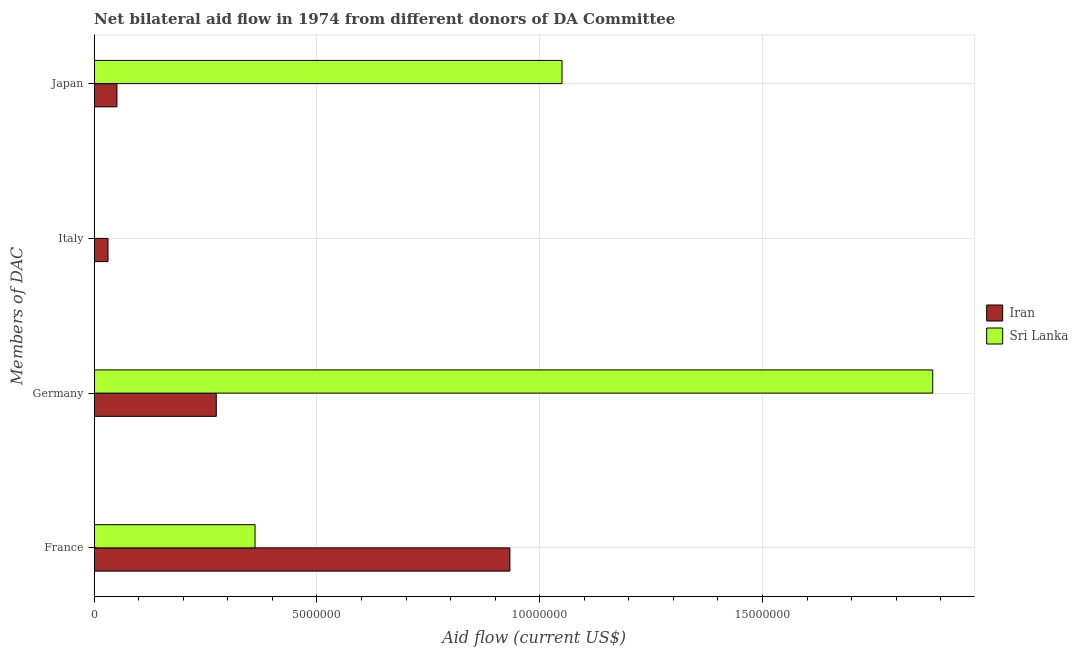Are the number of bars per tick equal to the number of legend labels?
Your answer should be compact. No. Are the number of bars on each tick of the Y-axis equal?
Your answer should be compact. No. How many bars are there on the 4th tick from the top?
Give a very brief answer. 2. What is the amount of aid given by france in Sri Lanka?
Provide a succinct answer. 3.61e+06. Across all countries, what is the maximum amount of aid given by germany?
Your answer should be compact. 1.88e+07. Across all countries, what is the minimum amount of aid given by italy?
Offer a very short reply. 0. In which country was the amount of aid given by italy maximum?
Your answer should be very brief. Iran. What is the total amount of aid given by france in the graph?
Ensure brevity in your answer.  1.29e+07. What is the difference between the amount of aid given by france in Iran and that in Sri Lanka?
Give a very brief answer. 5.72e+06. What is the difference between the amount of aid given by germany in Iran and the amount of aid given by italy in Sri Lanka?
Keep it short and to the point. 2.74e+06. What is the average amount of aid given by italy per country?
Your answer should be compact. 1.55e+05. What is the difference between the amount of aid given by germany and amount of aid given by italy in Iran?
Offer a terse response. 2.43e+06. In how many countries, is the amount of aid given by france greater than 12000000 US$?
Your answer should be compact. 0. What is the ratio of the amount of aid given by germany in Sri Lanka to that in Iran?
Offer a terse response. 6.87. Is the difference between the amount of aid given by france in Iran and Sri Lanka greater than the difference between the amount of aid given by japan in Iran and Sri Lanka?
Keep it short and to the point. Yes. What is the difference between the highest and the second highest amount of aid given by france?
Keep it short and to the point. 5.72e+06. What is the difference between the highest and the lowest amount of aid given by germany?
Ensure brevity in your answer.  1.61e+07. Are all the bars in the graph horizontal?
Make the answer very short. Yes. What is the difference between two consecutive major ticks on the X-axis?
Provide a short and direct response. 5.00e+06. Where does the legend appear in the graph?
Offer a very short reply. Center right. How many legend labels are there?
Ensure brevity in your answer.  2. How are the legend labels stacked?
Offer a very short reply. Vertical. What is the title of the graph?
Provide a succinct answer. Net bilateral aid flow in 1974 from different donors of DA Committee. What is the label or title of the Y-axis?
Give a very brief answer. Members of DAC. What is the Aid flow (current US$) of Iran in France?
Your answer should be compact. 9.33e+06. What is the Aid flow (current US$) in Sri Lanka in France?
Keep it short and to the point. 3.61e+06. What is the Aid flow (current US$) of Iran in Germany?
Make the answer very short. 2.74e+06. What is the Aid flow (current US$) in Sri Lanka in Germany?
Offer a very short reply. 1.88e+07. What is the Aid flow (current US$) in Sri Lanka in Italy?
Your answer should be compact. 0. What is the Aid flow (current US$) in Iran in Japan?
Your response must be concise. 5.10e+05. What is the Aid flow (current US$) in Sri Lanka in Japan?
Your answer should be very brief. 1.05e+07. Across all Members of DAC, what is the maximum Aid flow (current US$) in Iran?
Make the answer very short. 9.33e+06. Across all Members of DAC, what is the maximum Aid flow (current US$) in Sri Lanka?
Offer a very short reply. 1.88e+07. Across all Members of DAC, what is the minimum Aid flow (current US$) in Iran?
Give a very brief answer. 3.10e+05. Across all Members of DAC, what is the minimum Aid flow (current US$) in Sri Lanka?
Provide a short and direct response. 0. What is the total Aid flow (current US$) of Iran in the graph?
Your answer should be compact. 1.29e+07. What is the total Aid flow (current US$) in Sri Lanka in the graph?
Provide a short and direct response. 3.29e+07. What is the difference between the Aid flow (current US$) of Iran in France and that in Germany?
Your response must be concise. 6.59e+06. What is the difference between the Aid flow (current US$) in Sri Lanka in France and that in Germany?
Your answer should be very brief. -1.52e+07. What is the difference between the Aid flow (current US$) in Iran in France and that in Italy?
Offer a terse response. 9.02e+06. What is the difference between the Aid flow (current US$) of Iran in France and that in Japan?
Keep it short and to the point. 8.82e+06. What is the difference between the Aid flow (current US$) of Sri Lanka in France and that in Japan?
Your response must be concise. -6.89e+06. What is the difference between the Aid flow (current US$) in Iran in Germany and that in Italy?
Offer a very short reply. 2.43e+06. What is the difference between the Aid flow (current US$) in Iran in Germany and that in Japan?
Provide a short and direct response. 2.23e+06. What is the difference between the Aid flow (current US$) in Sri Lanka in Germany and that in Japan?
Keep it short and to the point. 8.32e+06. What is the difference between the Aid flow (current US$) in Iran in France and the Aid flow (current US$) in Sri Lanka in Germany?
Your answer should be very brief. -9.49e+06. What is the difference between the Aid flow (current US$) in Iran in France and the Aid flow (current US$) in Sri Lanka in Japan?
Your answer should be compact. -1.17e+06. What is the difference between the Aid flow (current US$) in Iran in Germany and the Aid flow (current US$) in Sri Lanka in Japan?
Your answer should be very brief. -7.76e+06. What is the difference between the Aid flow (current US$) in Iran in Italy and the Aid flow (current US$) in Sri Lanka in Japan?
Your answer should be compact. -1.02e+07. What is the average Aid flow (current US$) in Iran per Members of DAC?
Your response must be concise. 3.22e+06. What is the average Aid flow (current US$) in Sri Lanka per Members of DAC?
Make the answer very short. 8.23e+06. What is the difference between the Aid flow (current US$) in Iran and Aid flow (current US$) in Sri Lanka in France?
Give a very brief answer. 5.72e+06. What is the difference between the Aid flow (current US$) in Iran and Aid flow (current US$) in Sri Lanka in Germany?
Provide a short and direct response. -1.61e+07. What is the difference between the Aid flow (current US$) of Iran and Aid flow (current US$) of Sri Lanka in Japan?
Make the answer very short. -9.99e+06. What is the ratio of the Aid flow (current US$) in Iran in France to that in Germany?
Give a very brief answer. 3.41. What is the ratio of the Aid flow (current US$) of Sri Lanka in France to that in Germany?
Your answer should be compact. 0.19. What is the ratio of the Aid flow (current US$) of Iran in France to that in Italy?
Give a very brief answer. 30.1. What is the ratio of the Aid flow (current US$) of Iran in France to that in Japan?
Offer a terse response. 18.29. What is the ratio of the Aid flow (current US$) of Sri Lanka in France to that in Japan?
Make the answer very short. 0.34. What is the ratio of the Aid flow (current US$) in Iran in Germany to that in Italy?
Keep it short and to the point. 8.84. What is the ratio of the Aid flow (current US$) in Iran in Germany to that in Japan?
Give a very brief answer. 5.37. What is the ratio of the Aid flow (current US$) of Sri Lanka in Germany to that in Japan?
Your answer should be compact. 1.79. What is the ratio of the Aid flow (current US$) in Iran in Italy to that in Japan?
Ensure brevity in your answer.  0.61. What is the difference between the highest and the second highest Aid flow (current US$) in Iran?
Your answer should be compact. 6.59e+06. What is the difference between the highest and the second highest Aid flow (current US$) in Sri Lanka?
Offer a very short reply. 8.32e+06. What is the difference between the highest and the lowest Aid flow (current US$) of Iran?
Provide a short and direct response. 9.02e+06. What is the difference between the highest and the lowest Aid flow (current US$) in Sri Lanka?
Offer a very short reply. 1.88e+07. 